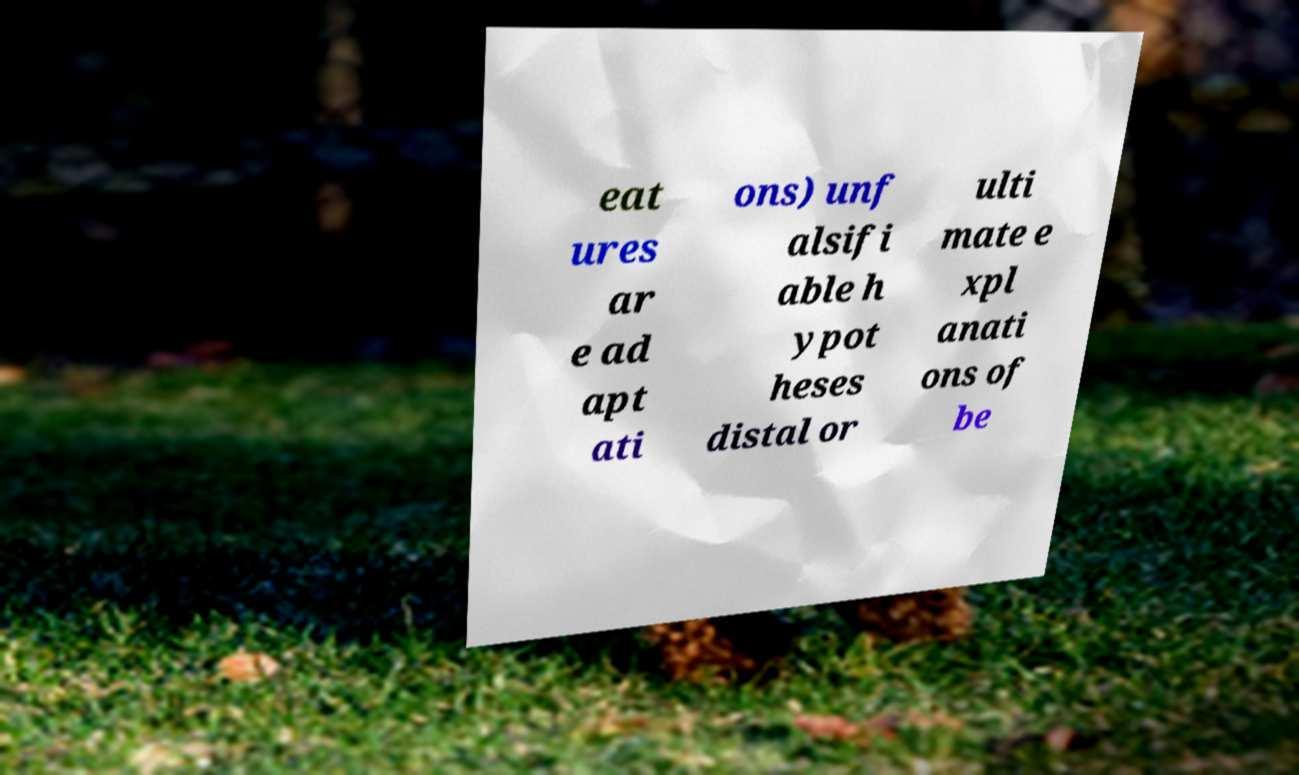I need the written content from this picture converted into text. Can you do that? eat ures ar e ad apt ati ons) unf alsifi able h ypot heses distal or ulti mate e xpl anati ons of be 